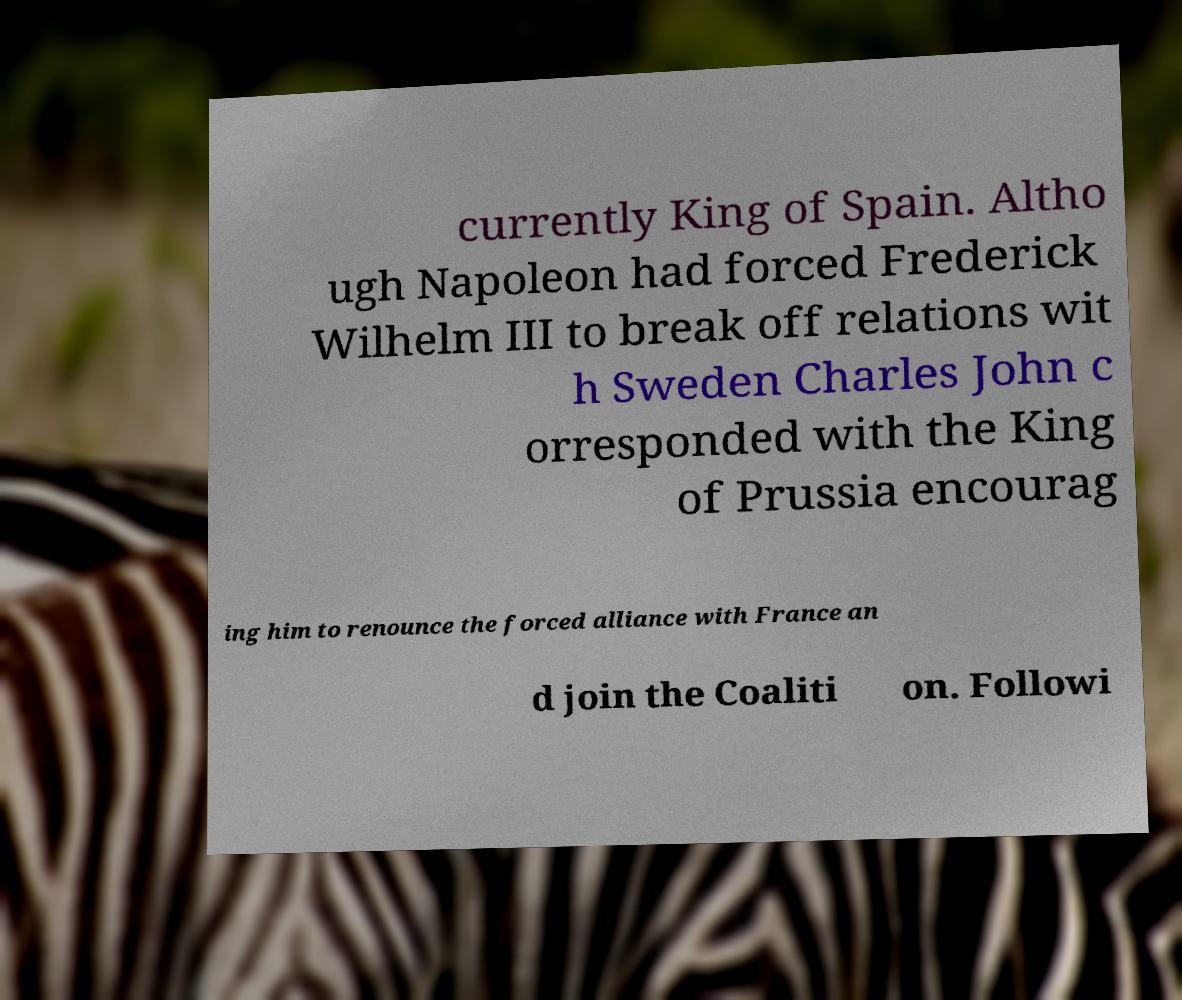Could you assist in decoding the text presented in this image and type it out clearly? currently King of Spain. Altho ugh Napoleon had forced Frederick Wilhelm III to break off relations wit h Sweden Charles John c orresponded with the King of Prussia encourag ing him to renounce the forced alliance with France an d join the Coaliti on. Followi 